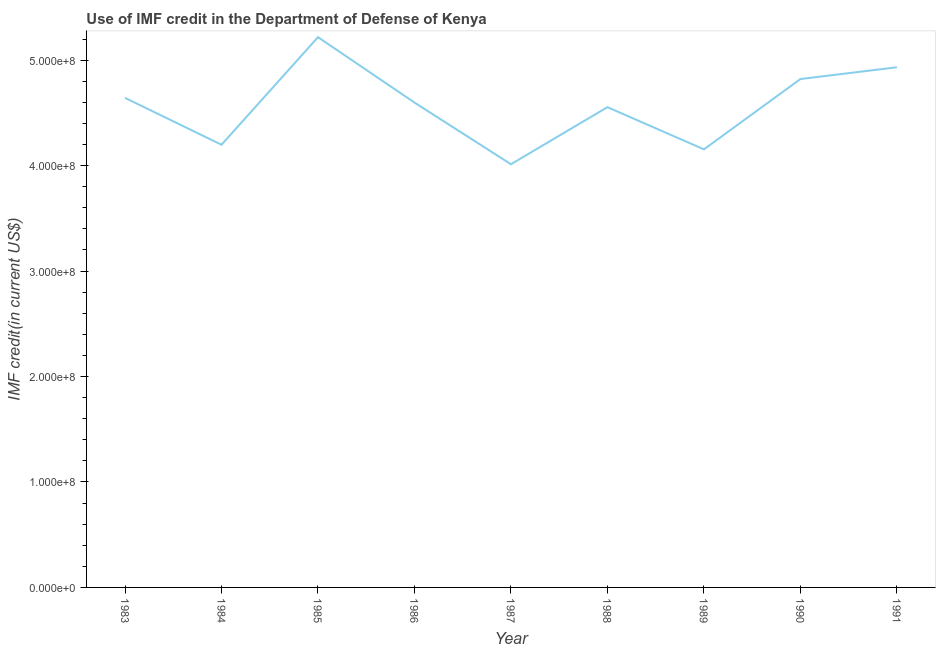What is the use of imf credit in dod in 1985?
Ensure brevity in your answer.  5.22e+08. Across all years, what is the maximum use of imf credit in dod?
Provide a short and direct response. 5.22e+08. Across all years, what is the minimum use of imf credit in dod?
Offer a very short reply. 4.01e+08. What is the sum of the use of imf credit in dod?
Your answer should be compact. 4.11e+09. What is the difference between the use of imf credit in dod in 1983 and 1985?
Provide a short and direct response. -5.76e+07. What is the average use of imf credit in dod per year?
Ensure brevity in your answer.  4.57e+08. What is the median use of imf credit in dod?
Offer a terse response. 4.60e+08. Do a majority of the years between 1987 and 1988 (inclusive) have use of imf credit in dod greater than 360000000 US$?
Make the answer very short. Yes. What is the ratio of the use of imf credit in dod in 1989 to that in 1991?
Your answer should be very brief. 0.84. Is the difference between the use of imf credit in dod in 1984 and 1988 greater than the difference between any two years?
Ensure brevity in your answer.  No. What is the difference between the highest and the second highest use of imf credit in dod?
Provide a short and direct response. 2.85e+07. What is the difference between the highest and the lowest use of imf credit in dod?
Make the answer very short. 1.20e+08. Does the use of imf credit in dod monotonically increase over the years?
Provide a short and direct response. No. How many lines are there?
Give a very brief answer. 1. What is the difference between two consecutive major ticks on the Y-axis?
Give a very brief answer. 1.00e+08. Are the values on the major ticks of Y-axis written in scientific E-notation?
Ensure brevity in your answer.  Yes. Does the graph contain any zero values?
Your answer should be very brief. No. Does the graph contain grids?
Your answer should be very brief. No. What is the title of the graph?
Offer a very short reply. Use of IMF credit in the Department of Defense of Kenya. What is the label or title of the Y-axis?
Keep it short and to the point. IMF credit(in current US$). What is the IMF credit(in current US$) in 1983?
Give a very brief answer. 4.64e+08. What is the IMF credit(in current US$) in 1984?
Your response must be concise. 4.20e+08. What is the IMF credit(in current US$) of 1985?
Offer a terse response. 5.22e+08. What is the IMF credit(in current US$) in 1986?
Provide a succinct answer. 4.60e+08. What is the IMF credit(in current US$) in 1987?
Your answer should be compact. 4.01e+08. What is the IMF credit(in current US$) in 1988?
Provide a succinct answer. 4.55e+08. What is the IMF credit(in current US$) of 1989?
Your answer should be very brief. 4.15e+08. What is the IMF credit(in current US$) of 1990?
Ensure brevity in your answer.  4.82e+08. What is the IMF credit(in current US$) in 1991?
Provide a short and direct response. 4.93e+08. What is the difference between the IMF credit(in current US$) in 1983 and 1984?
Give a very brief answer. 4.44e+07. What is the difference between the IMF credit(in current US$) in 1983 and 1985?
Your response must be concise. -5.76e+07. What is the difference between the IMF credit(in current US$) in 1983 and 1986?
Provide a succinct answer. 4.43e+06. What is the difference between the IMF credit(in current US$) in 1983 and 1987?
Give a very brief answer. 6.29e+07. What is the difference between the IMF credit(in current US$) in 1983 and 1988?
Offer a very short reply. 8.79e+06. What is the difference between the IMF credit(in current US$) in 1983 and 1989?
Your response must be concise. 4.88e+07. What is the difference between the IMF credit(in current US$) in 1983 and 1990?
Ensure brevity in your answer.  -1.79e+07. What is the difference between the IMF credit(in current US$) in 1983 and 1991?
Give a very brief answer. -2.90e+07. What is the difference between the IMF credit(in current US$) in 1984 and 1985?
Keep it short and to the point. -1.02e+08. What is the difference between the IMF credit(in current US$) in 1984 and 1986?
Offer a terse response. -4.00e+07. What is the difference between the IMF credit(in current US$) in 1984 and 1987?
Ensure brevity in your answer.  1.85e+07. What is the difference between the IMF credit(in current US$) in 1984 and 1988?
Your response must be concise. -3.56e+07. What is the difference between the IMF credit(in current US$) in 1984 and 1989?
Your response must be concise. 4.38e+06. What is the difference between the IMF credit(in current US$) in 1984 and 1990?
Your answer should be very brief. -6.23e+07. What is the difference between the IMF credit(in current US$) in 1984 and 1991?
Your response must be concise. -7.35e+07. What is the difference between the IMF credit(in current US$) in 1985 and 1986?
Give a very brief answer. 6.20e+07. What is the difference between the IMF credit(in current US$) in 1985 and 1987?
Your answer should be compact. 1.20e+08. What is the difference between the IMF credit(in current US$) in 1985 and 1988?
Provide a short and direct response. 6.64e+07. What is the difference between the IMF credit(in current US$) in 1985 and 1989?
Keep it short and to the point. 1.06e+08. What is the difference between the IMF credit(in current US$) in 1985 and 1990?
Your answer should be very brief. 3.97e+07. What is the difference between the IMF credit(in current US$) in 1985 and 1991?
Keep it short and to the point. 2.85e+07. What is the difference between the IMF credit(in current US$) in 1986 and 1987?
Your response must be concise. 5.85e+07. What is the difference between the IMF credit(in current US$) in 1986 and 1988?
Provide a short and direct response. 4.36e+06. What is the difference between the IMF credit(in current US$) in 1986 and 1989?
Provide a short and direct response. 4.44e+07. What is the difference between the IMF credit(in current US$) in 1986 and 1990?
Provide a succinct answer. -2.23e+07. What is the difference between the IMF credit(in current US$) in 1986 and 1991?
Provide a succinct answer. -3.35e+07. What is the difference between the IMF credit(in current US$) in 1987 and 1988?
Ensure brevity in your answer.  -5.41e+07. What is the difference between the IMF credit(in current US$) in 1987 and 1989?
Your response must be concise. -1.41e+07. What is the difference between the IMF credit(in current US$) in 1987 and 1990?
Your answer should be compact. -8.08e+07. What is the difference between the IMF credit(in current US$) in 1987 and 1991?
Provide a short and direct response. -9.20e+07. What is the difference between the IMF credit(in current US$) in 1988 and 1989?
Offer a terse response. 4.00e+07. What is the difference between the IMF credit(in current US$) in 1988 and 1990?
Keep it short and to the point. -2.67e+07. What is the difference between the IMF credit(in current US$) in 1988 and 1991?
Your response must be concise. -3.78e+07. What is the difference between the IMF credit(in current US$) in 1989 and 1990?
Your response must be concise. -6.67e+07. What is the difference between the IMF credit(in current US$) in 1989 and 1991?
Your response must be concise. -7.78e+07. What is the difference between the IMF credit(in current US$) in 1990 and 1991?
Make the answer very short. -1.12e+07. What is the ratio of the IMF credit(in current US$) in 1983 to that in 1984?
Offer a very short reply. 1.11. What is the ratio of the IMF credit(in current US$) in 1983 to that in 1985?
Keep it short and to the point. 0.89. What is the ratio of the IMF credit(in current US$) in 1983 to that in 1986?
Make the answer very short. 1.01. What is the ratio of the IMF credit(in current US$) in 1983 to that in 1987?
Provide a short and direct response. 1.16. What is the ratio of the IMF credit(in current US$) in 1983 to that in 1988?
Offer a very short reply. 1.02. What is the ratio of the IMF credit(in current US$) in 1983 to that in 1989?
Provide a short and direct response. 1.12. What is the ratio of the IMF credit(in current US$) in 1983 to that in 1990?
Give a very brief answer. 0.96. What is the ratio of the IMF credit(in current US$) in 1983 to that in 1991?
Your answer should be compact. 0.94. What is the ratio of the IMF credit(in current US$) in 1984 to that in 1985?
Ensure brevity in your answer.  0.81. What is the ratio of the IMF credit(in current US$) in 1984 to that in 1987?
Offer a very short reply. 1.05. What is the ratio of the IMF credit(in current US$) in 1984 to that in 1988?
Your answer should be compact. 0.92. What is the ratio of the IMF credit(in current US$) in 1984 to that in 1990?
Your answer should be very brief. 0.87. What is the ratio of the IMF credit(in current US$) in 1984 to that in 1991?
Ensure brevity in your answer.  0.85. What is the ratio of the IMF credit(in current US$) in 1985 to that in 1986?
Offer a very short reply. 1.14. What is the ratio of the IMF credit(in current US$) in 1985 to that in 1988?
Give a very brief answer. 1.15. What is the ratio of the IMF credit(in current US$) in 1985 to that in 1989?
Ensure brevity in your answer.  1.26. What is the ratio of the IMF credit(in current US$) in 1985 to that in 1990?
Your answer should be very brief. 1.08. What is the ratio of the IMF credit(in current US$) in 1985 to that in 1991?
Keep it short and to the point. 1.06. What is the ratio of the IMF credit(in current US$) in 1986 to that in 1987?
Keep it short and to the point. 1.15. What is the ratio of the IMF credit(in current US$) in 1986 to that in 1988?
Ensure brevity in your answer.  1.01. What is the ratio of the IMF credit(in current US$) in 1986 to that in 1989?
Provide a short and direct response. 1.11. What is the ratio of the IMF credit(in current US$) in 1986 to that in 1990?
Offer a terse response. 0.95. What is the ratio of the IMF credit(in current US$) in 1986 to that in 1991?
Your answer should be compact. 0.93. What is the ratio of the IMF credit(in current US$) in 1987 to that in 1988?
Offer a terse response. 0.88. What is the ratio of the IMF credit(in current US$) in 1987 to that in 1990?
Make the answer very short. 0.83. What is the ratio of the IMF credit(in current US$) in 1987 to that in 1991?
Give a very brief answer. 0.81. What is the ratio of the IMF credit(in current US$) in 1988 to that in 1989?
Your answer should be very brief. 1.1. What is the ratio of the IMF credit(in current US$) in 1988 to that in 1990?
Keep it short and to the point. 0.94. What is the ratio of the IMF credit(in current US$) in 1988 to that in 1991?
Offer a terse response. 0.92. What is the ratio of the IMF credit(in current US$) in 1989 to that in 1990?
Your answer should be very brief. 0.86. What is the ratio of the IMF credit(in current US$) in 1989 to that in 1991?
Your answer should be very brief. 0.84. 